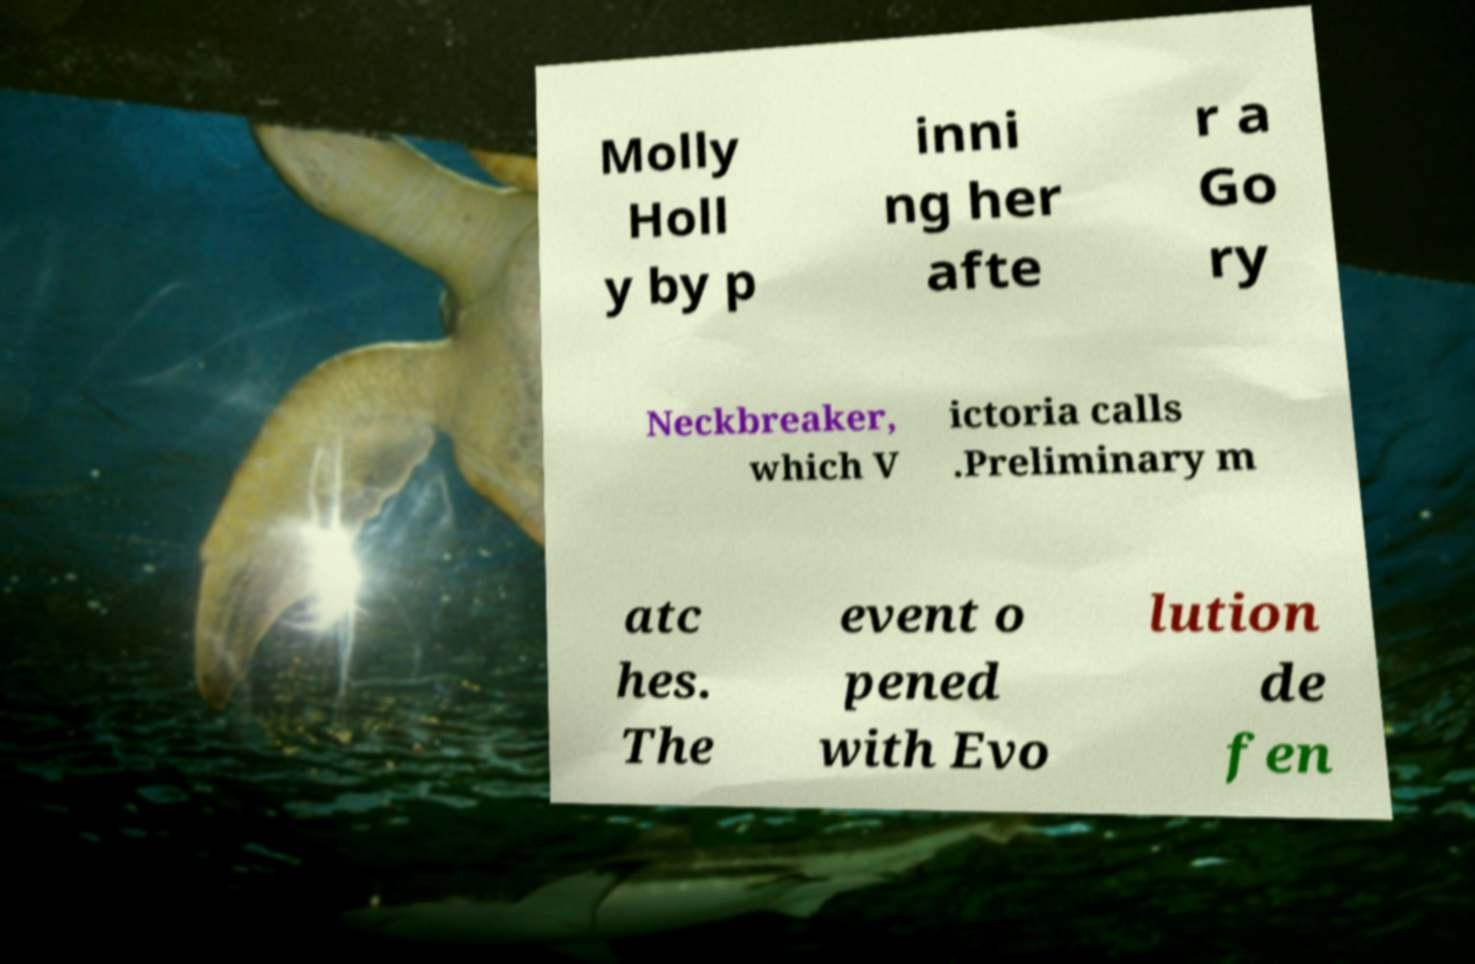I need the written content from this picture converted into text. Can you do that? Molly Holl y by p inni ng her afte r a Go ry Neckbreaker, which V ictoria calls .Preliminary m atc hes. The event o pened with Evo lution de fen 